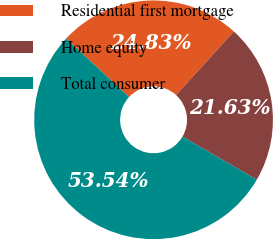Convert chart to OTSL. <chart><loc_0><loc_0><loc_500><loc_500><pie_chart><fcel>Residential first mortgage<fcel>Home equity<fcel>Total consumer<nl><fcel>24.83%<fcel>21.63%<fcel>53.54%<nl></chart> 